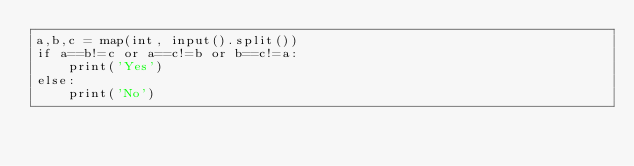Convert code to text. <code><loc_0><loc_0><loc_500><loc_500><_Python_>a,b,c = map(int, input().split())
if a==b!=c or a==c!=b or b==c!=a:
    print('Yes')
else:
    print('No')</code> 